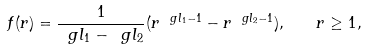Convert formula to latex. <formula><loc_0><loc_0><loc_500><loc_500>f ( r ) = \frac { 1 } { \ g l _ { 1 } - \ g l _ { 2 } } ( r ^ { \ g l _ { 1 } - 1 } - r ^ { \ g l _ { 2 } - 1 } ) , \quad r \geq 1 ,</formula> 